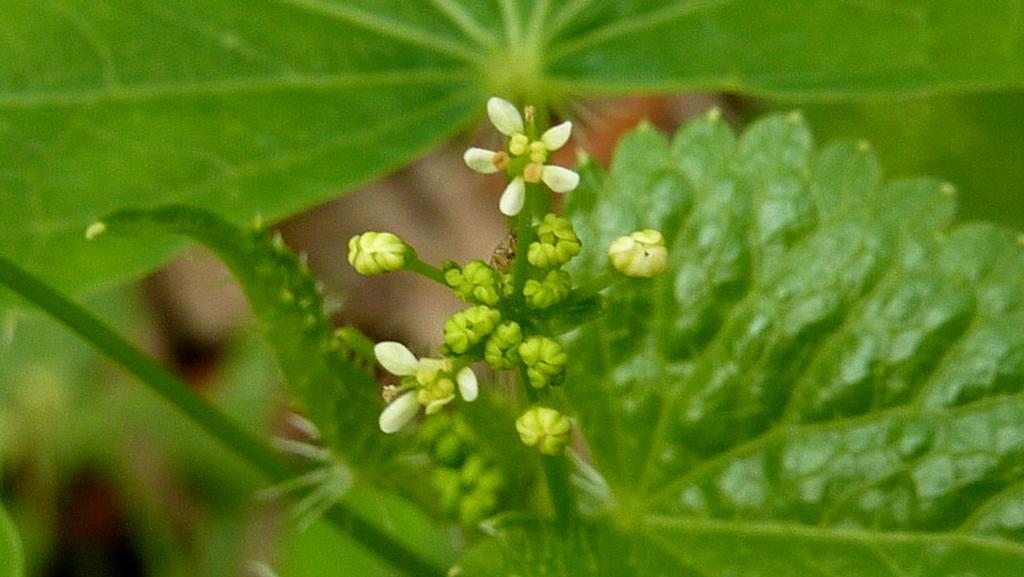Describe this image in one or two sentences. In this picture there is a flower and buds to a plant and there are leaves. 